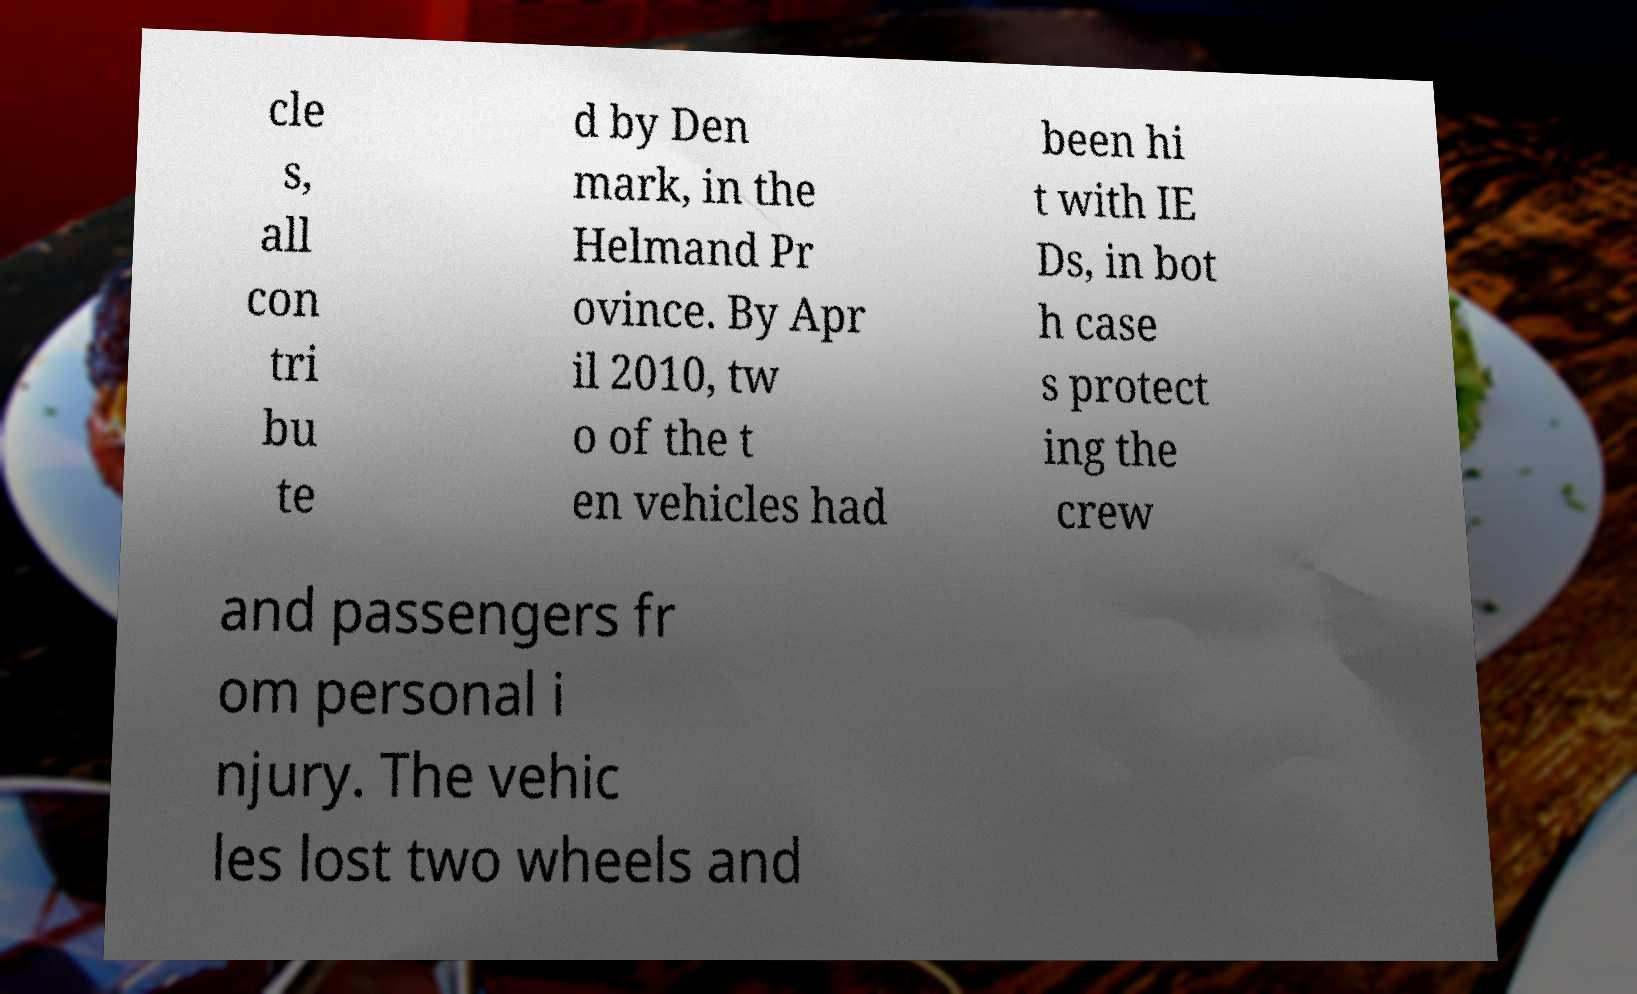Can you accurately transcribe the text from the provided image for me? cle s, all con tri bu te d by Den mark, in the Helmand Pr ovince. By Apr il 2010, tw o of the t en vehicles had been hi t with IE Ds, in bot h case s protect ing the crew and passengers fr om personal i njury. The vehic les lost two wheels and 